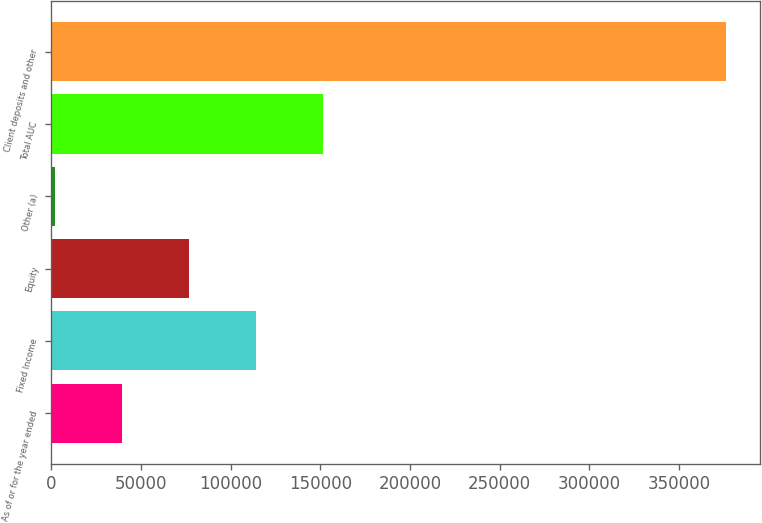<chart> <loc_0><loc_0><loc_500><loc_500><bar_chart><fcel>As of or for the year ended<fcel>Fixed Income<fcel>Equity<fcel>Other (a)<fcel>Total AUC<fcel>Client deposits and other<nl><fcel>39362.1<fcel>114234<fcel>76798.2<fcel>1926<fcel>151670<fcel>376287<nl></chart> 